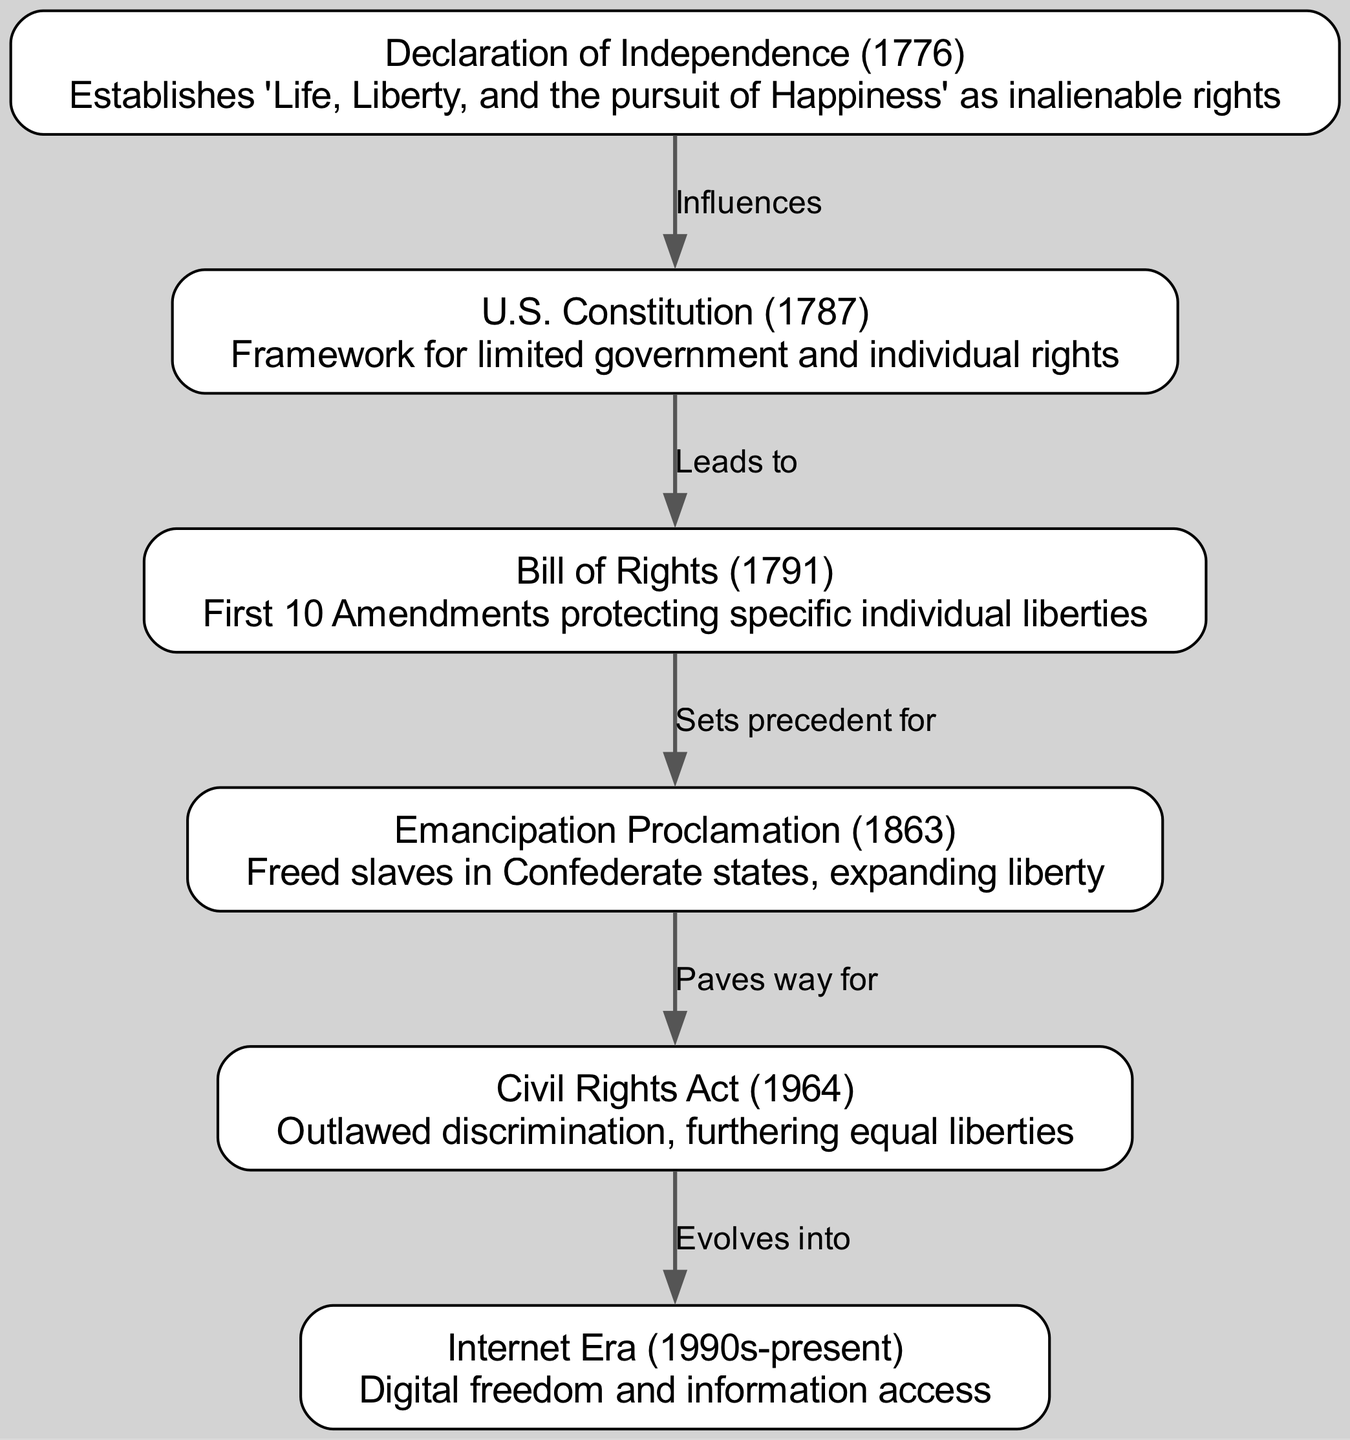What year was the Declaration of Independence signed? The diagram indicates that the Declaration of Independence was established in 1776, as noted in the corresponding node.
Answer: 1776 What does the Bill of Rights protect? The Bill of Rights, as described in the diagram, consists of the first 10 Amendments that specifically protect individual liberties.
Answer: Individual liberties How many nodes are there in the diagram? By counting the distinct nodes listed in the diagram, we find there are a total of 6 nodes documenting various milestones in the evolution of individual liberty.
Answer: 6 Which document influenced the U.S. Constitution? According to the directed edge between the nodes, the Declaration of Independence influences the U.S. Constitution, as specified in the relationship label.
Answer: Declaration of Independence What did the Emancipation Proclamation pave the way for? The diagram shows that the Emancipation Proclamation, which freed slaves in Confederate states, paved the way for the Civil Rights Act of 1964.
Answer: Civil Rights Act What is the relationship between the Civil Rights Act and the Internet Era? The diagram indicates an evolutionary flow where the Civil Rights Act evolves into the Internet Era, signifying a progression in individual liberty.
Answer: Evolves into How does the Bill of Rights relate to the Emancipation Proclamation? The edge from the Bill of Rights to the Emancipation Proclamation in the diagram suggests that the Bill of Rights sets a precedent for the freedoms addressed in the Emancipation Proclamation.
Answer: Sets precedent for What key concept is established by the Declaration of Independence? The first node highlights that the Declaration of Independence establishes 'Life, Liberty, and the pursuit of Happiness' as inalienable rights, a fundamental concept in American liberty.
Answer: Inalienable rights Which two documents are connected by the edge labeled "Paves way for"? The diagram establishes a connection between the Emancipation Proclamation and the Civil Rights Act via the labeled edge "Paves way for," indicating a direct influence.
Answer: Emancipation Proclamation and Civil Rights Act 